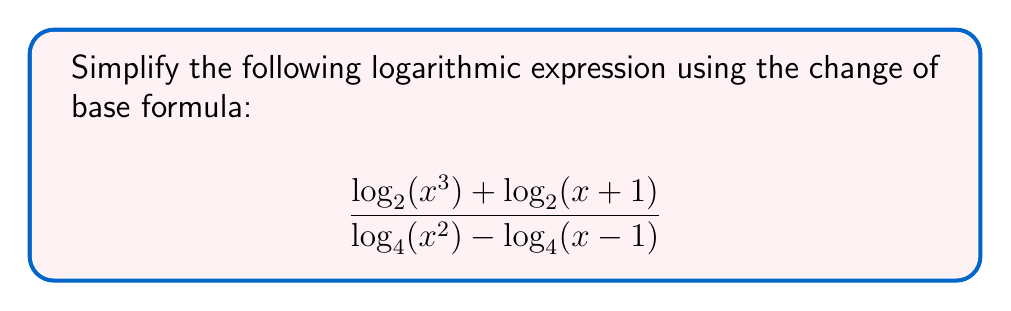Can you solve this math problem? Let's approach this step-by-step:

1) First, recall the change of base formula: 
   $$\log_a(b) = \frac{\ln(b)}{\ln(a)}$$

2) Apply this to each logarithm in the expression:

   $$\frac{\frac{\ln(x^3)}{\ln(2)} + \frac{\ln(x+1)}{\ln(2)}}{\frac{\ln(x^2)}{\ln(4)} - \frac{\ln(x-1)}{\ln(4)}}$$

3) Simplify the numerator:
   $$\frac{\ln(x^3) + \ln(x+1)}{\ln(2)}$$

4) Simplify the denominator:
   $$\frac{\ln(x^2) - \ln(x-1)}{\ln(4)}$$

5) Recall that $\ln(4) = \ln(2^2) = 2\ln(2)$. Apply this to the denominator:
   $$\frac{\ln(x^2) - \ln(x-1)}{2\ln(2)}$$

6) Now our expression looks like this:

   $$\frac{\frac{\ln(x^3) + \ln(x+1)}{\ln(2)}}{\frac{\ln(x^2) - \ln(x-1)}{2\ln(2)}}$$

7) The $\ln(2)$ cancels out in the numerator and denominator:

   $$\frac{2(\ln(x^3) + \ln(x+1))}{\ln(x^2) - \ln(x-1)}$$

8) Use the logarithm property $\ln(a^n) = n\ln(a)$:

   $$\frac{2(3\ln(x) + \ln(x+1))}{2\ln(x) - \ln(x-1)}$$

9) Distribute in the numerator:

   $$\frac{6\ln(x) + 2\ln(x+1)}{2\ln(x) - \ln(x-1)}$$

This is the simplest form using the change of base formula.
Answer: $$\frac{6\ln(x) + 2\ln(x+1)}{2\ln(x) - \ln(x-1)}$$ 